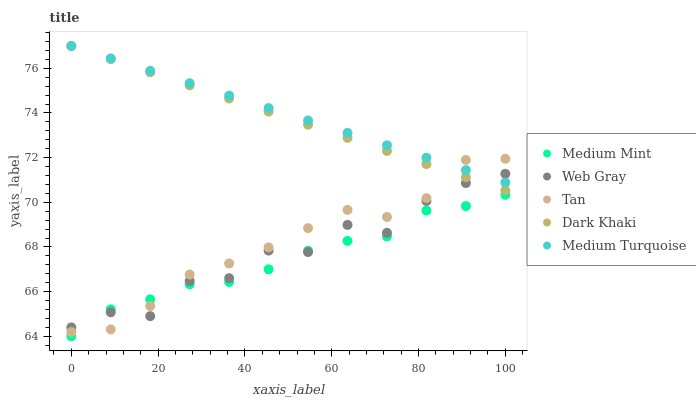Does Medium Mint have the minimum area under the curve?
Answer yes or no. Yes. Does Medium Turquoise have the maximum area under the curve?
Answer yes or no. Yes. Does Dark Khaki have the minimum area under the curve?
Answer yes or no. No. Does Dark Khaki have the maximum area under the curve?
Answer yes or no. No. Is Medium Turquoise the smoothest?
Answer yes or no. Yes. Is Web Gray the roughest?
Answer yes or no. Yes. Is Dark Khaki the smoothest?
Answer yes or no. No. Is Dark Khaki the roughest?
Answer yes or no. No. Does Medium Mint have the lowest value?
Answer yes or no. Yes. Does Dark Khaki have the lowest value?
Answer yes or no. No. Does Medium Turquoise have the highest value?
Answer yes or no. Yes. Does Tan have the highest value?
Answer yes or no. No. Is Medium Mint less than Medium Turquoise?
Answer yes or no. Yes. Is Dark Khaki greater than Medium Mint?
Answer yes or no. Yes. Does Web Gray intersect Medium Turquoise?
Answer yes or no. Yes. Is Web Gray less than Medium Turquoise?
Answer yes or no. No. Is Web Gray greater than Medium Turquoise?
Answer yes or no. No. Does Medium Mint intersect Medium Turquoise?
Answer yes or no. No. 